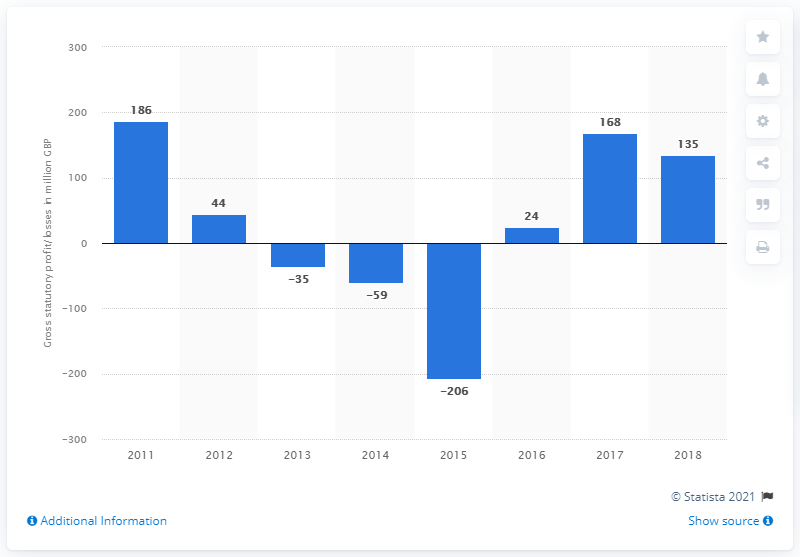Mention a couple of crucial points in this snapshot. Balfour Beatty Group's statutory profit in 2018 was 135.. 